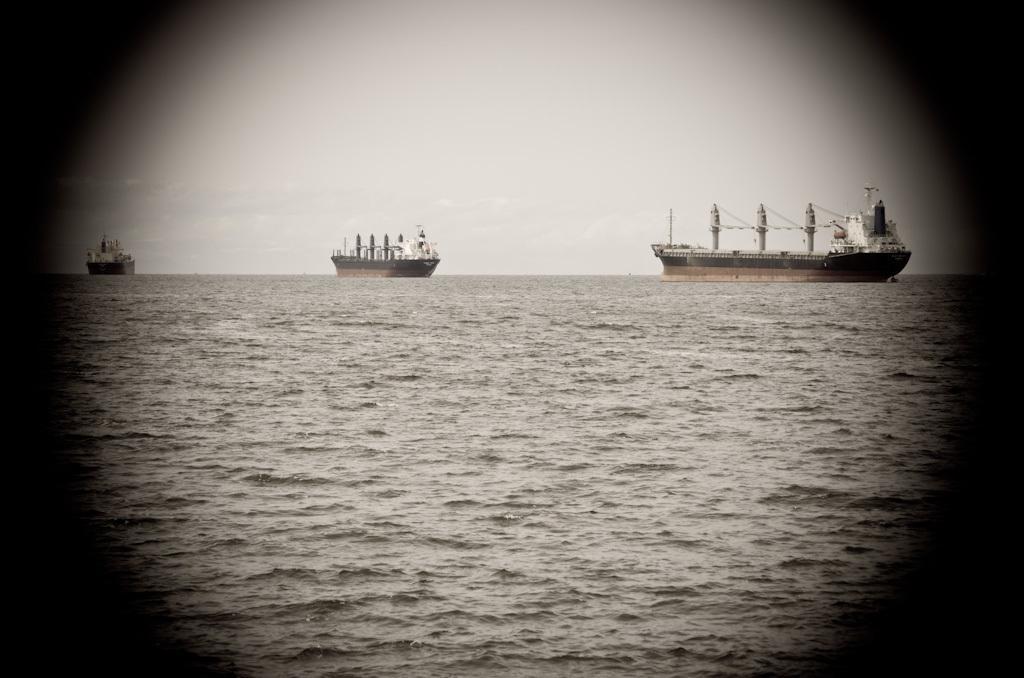In one or two sentences, can you explain what this image depicts? In the image I can see the water and few huge ships on the surface of the water. In the background I can see the sky. 